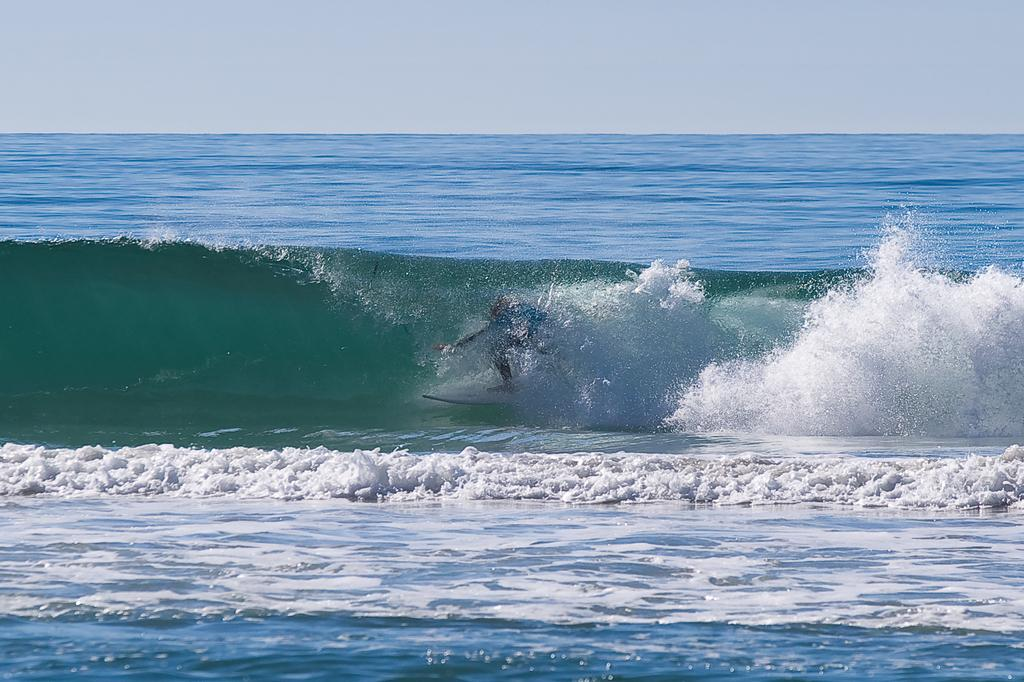What is the main subject of the image? There is a person in the image. What activity is the person engaged in? The person is surfing on the water. What type of stone is the person using to surf in the image? There is no stone present in the image; the person is surfing on the water using a surfboard. What type of flight is the person taking in the image? There is no flight present in the image; the person is surfing on the water. 